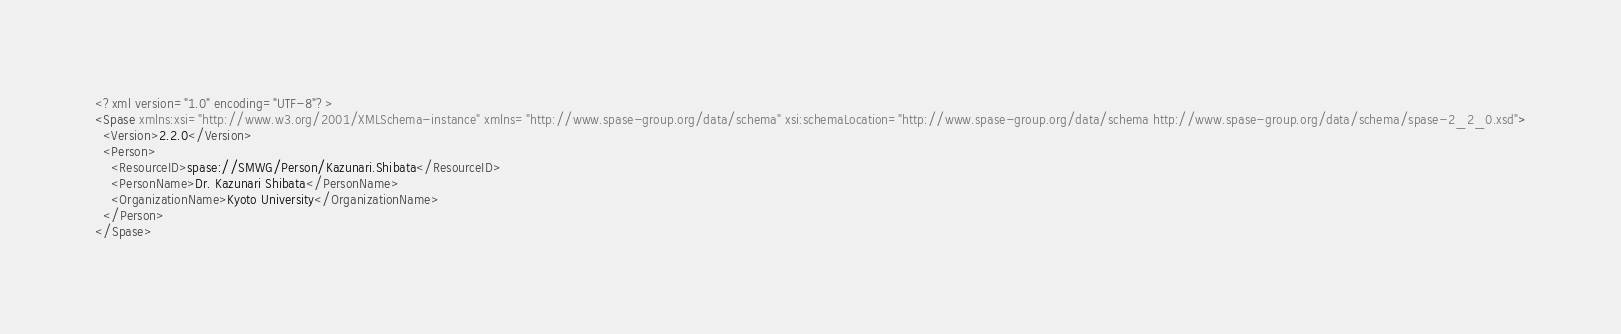<code> <loc_0><loc_0><loc_500><loc_500><_XML_><?xml version="1.0" encoding="UTF-8"?>
<Spase xmlns:xsi="http://www.w3.org/2001/XMLSchema-instance" xmlns="http://www.spase-group.org/data/schema" xsi:schemaLocation="http://www.spase-group.org/data/schema http://www.spase-group.org/data/schema/spase-2_2_0.xsd">
  <Version>2.2.0</Version>
  <Person>
    <ResourceID>spase://SMWG/Person/Kazunari.Shibata</ResourceID>
    <PersonName>Dr. Kazunari Shibata</PersonName>
    <OrganizationName>Kyoto University</OrganizationName>
  </Person>
</Spase>
</code> 